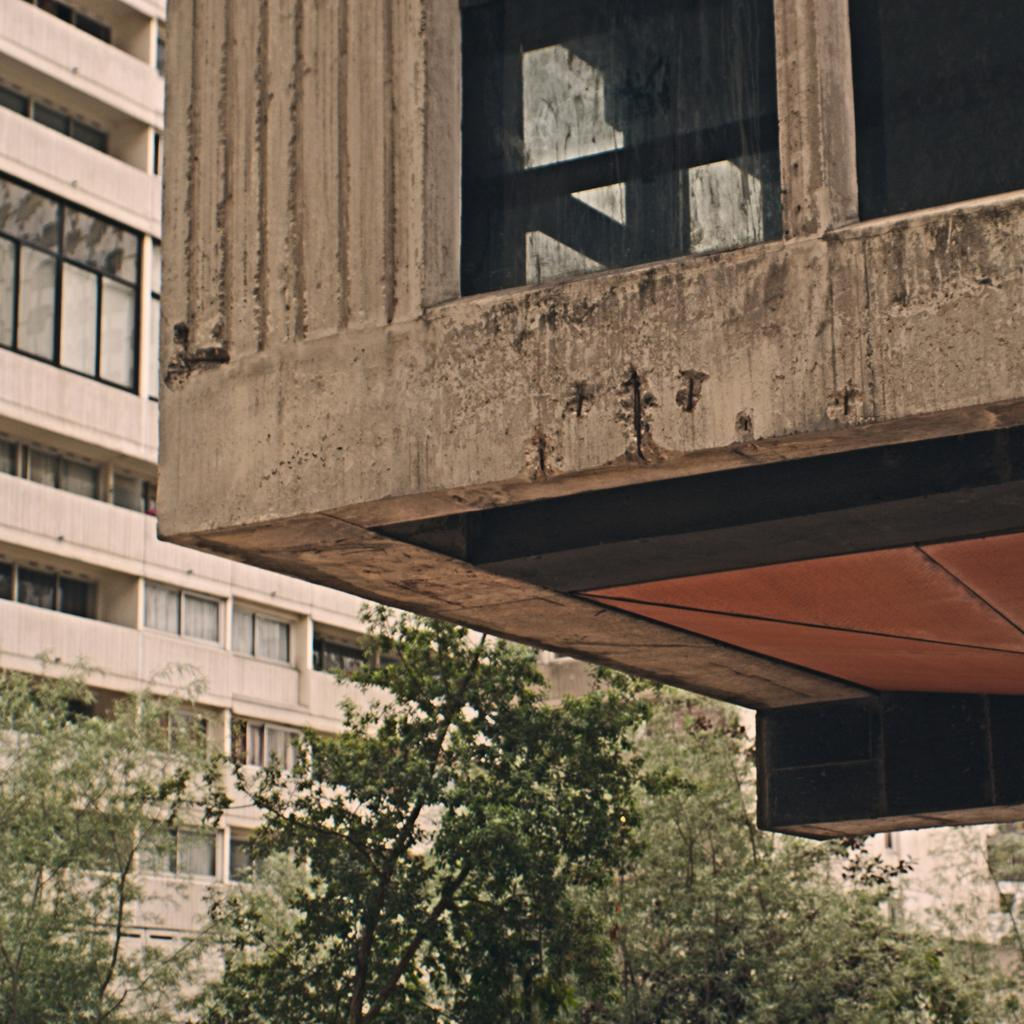What type of buildings can be seen in the image? There are buildings with glass windows in the image. What other elements can be observed in the image? Trees are present in the image. What type of notebook is being used to express anger in the image? There is no notebook or expression of anger present in the image. 